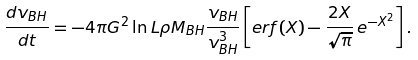Convert formula to latex. <formula><loc_0><loc_0><loc_500><loc_500>\frac { d v _ { B H } } { d t } = - 4 \pi G ^ { 2 } \ln L \rho M _ { B H } \frac { v _ { B H } } { v _ { B H } ^ { 3 } } \left [ e r f ( X ) - \frac { 2 X } { \sqrt { \pi } } \, e ^ { - X ^ { 2 } } \right ] .</formula> 